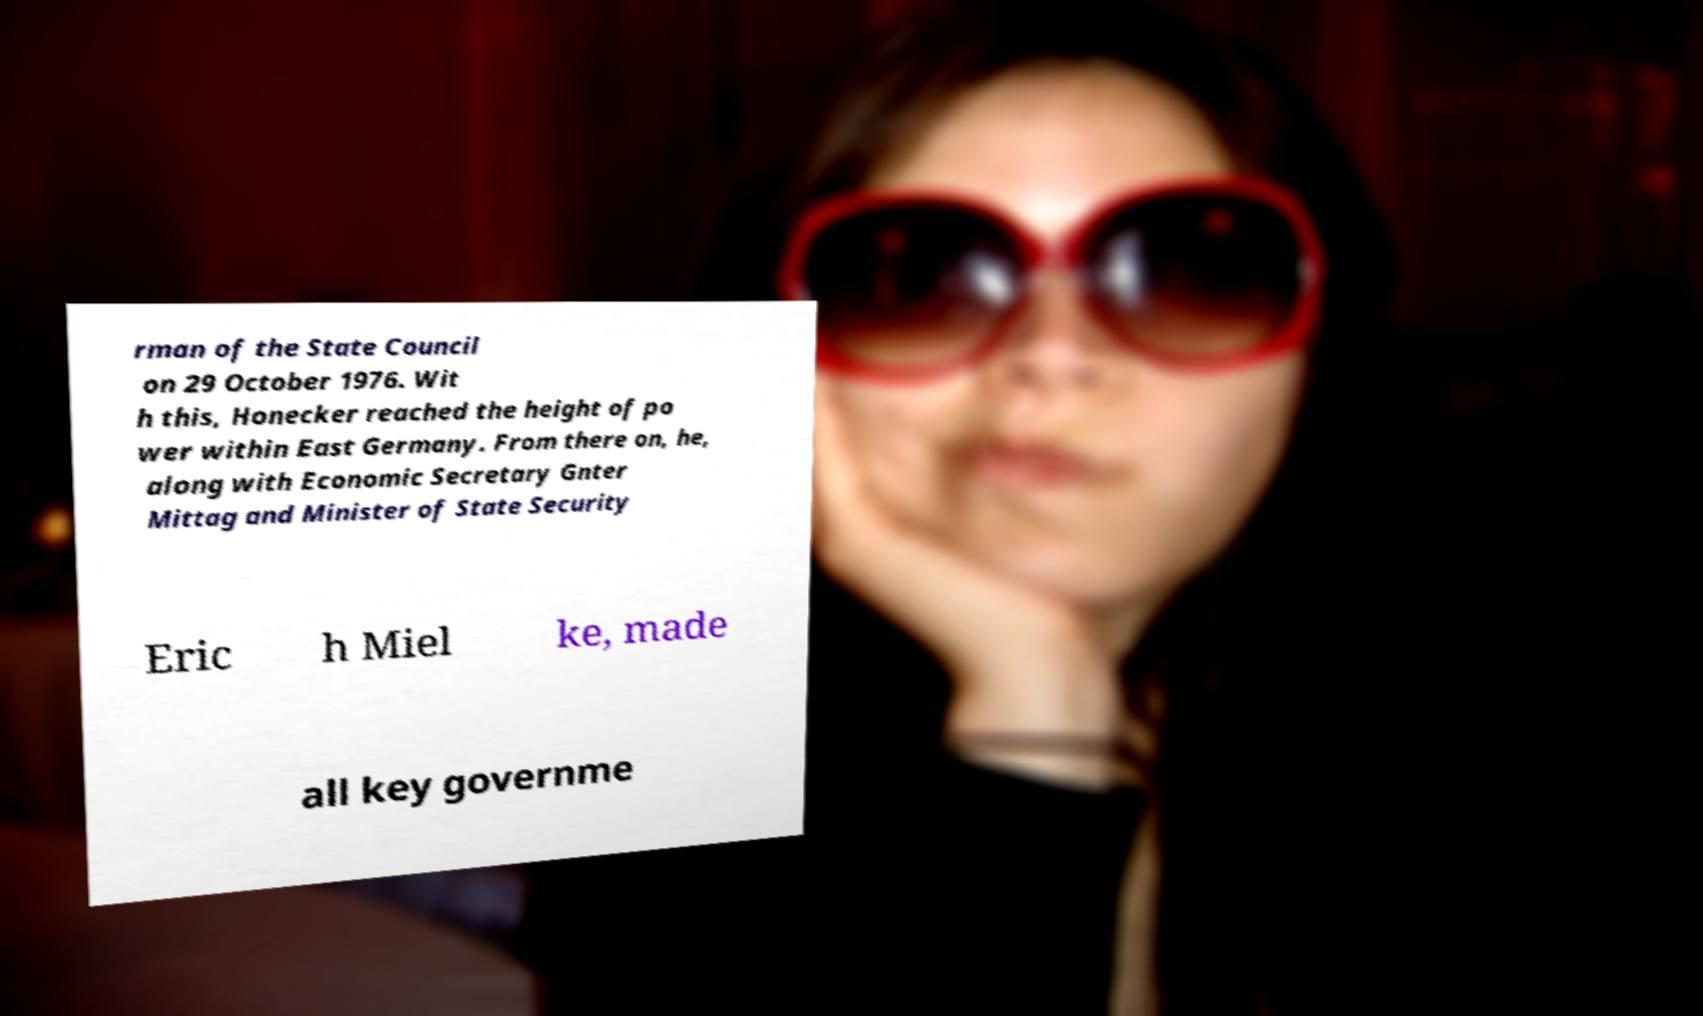Please identify and transcribe the text found in this image. rman of the State Council on 29 October 1976. Wit h this, Honecker reached the height of po wer within East Germany. From there on, he, along with Economic Secretary Gnter Mittag and Minister of State Security Eric h Miel ke, made all key governme 